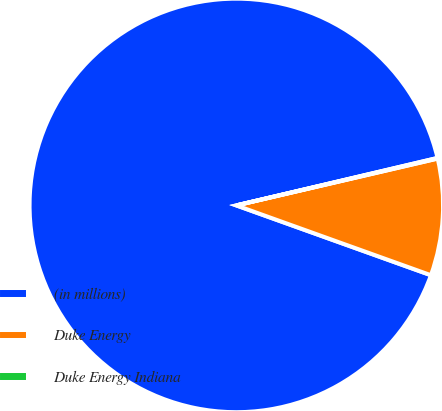Convert chart. <chart><loc_0><loc_0><loc_500><loc_500><pie_chart><fcel>(in millions)<fcel>Duke Energy<fcel>Duke Energy Indiana<nl><fcel>90.83%<fcel>9.12%<fcel>0.05%<nl></chart> 